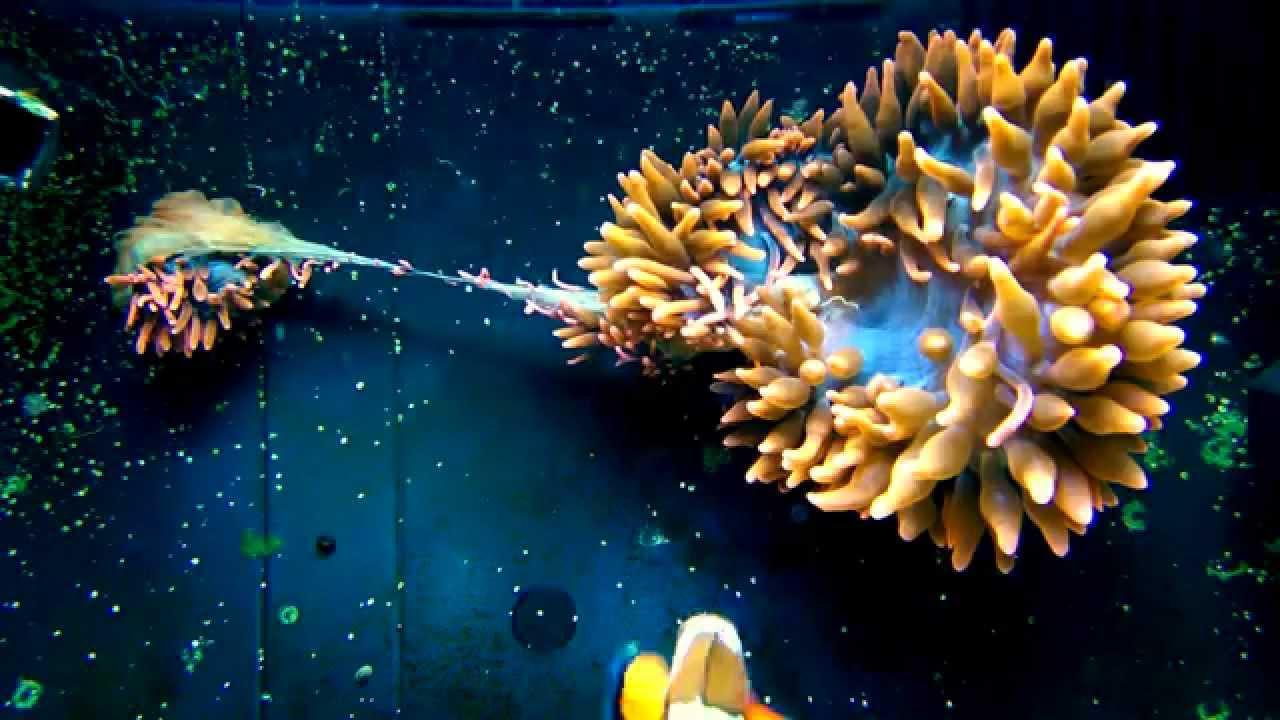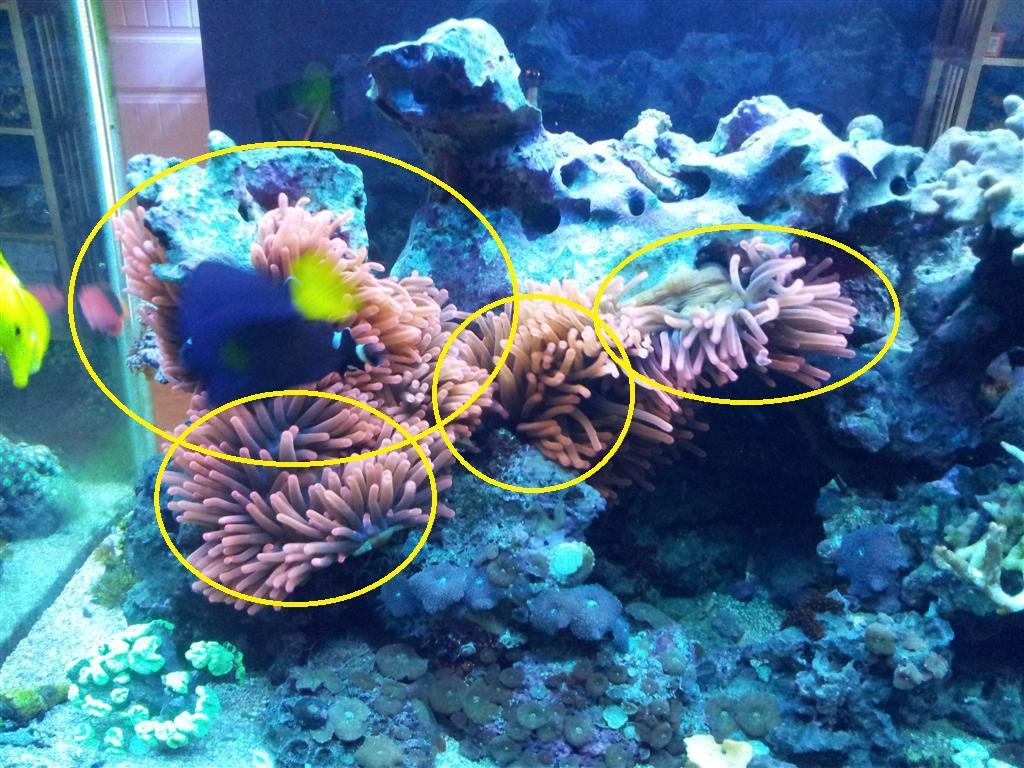The first image is the image on the left, the second image is the image on the right. For the images displayed, is the sentence "One image shows anemone with bulbous pink tendrils, and the other image includes orange-and-white clownfish colors by anemone tendrils." factually correct? Answer yes or no. No. The first image is the image on the left, the second image is the image on the right. Assess this claim about the two images: "In at least one image there is a single  pink corral reef with and open oval circle in the middle of the reef facing up.". Correct or not? Answer yes or no. No. 